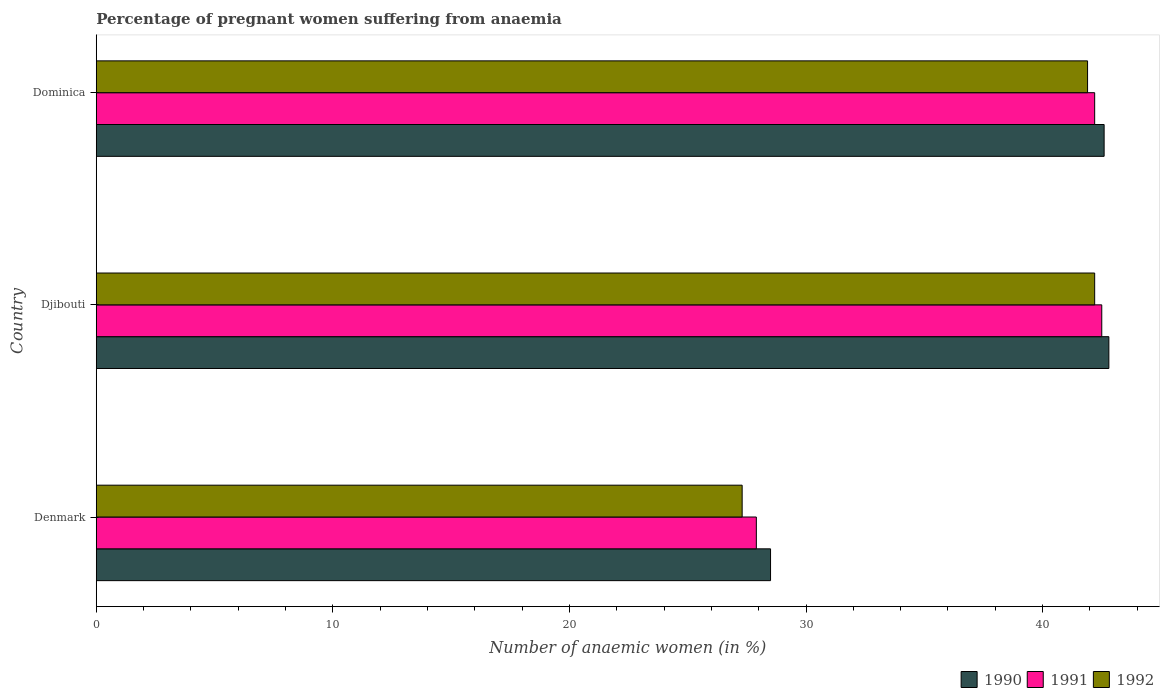How many bars are there on the 3rd tick from the bottom?
Ensure brevity in your answer.  3. What is the label of the 2nd group of bars from the top?
Your answer should be very brief. Djibouti. In how many cases, is the number of bars for a given country not equal to the number of legend labels?
Your answer should be compact. 0. What is the number of anaemic women in 1990 in Djibouti?
Provide a short and direct response. 42.8. Across all countries, what is the maximum number of anaemic women in 1990?
Your answer should be compact. 42.8. Across all countries, what is the minimum number of anaemic women in 1991?
Your answer should be very brief. 27.9. In which country was the number of anaemic women in 1991 maximum?
Your answer should be compact. Djibouti. In which country was the number of anaemic women in 1991 minimum?
Your answer should be compact. Denmark. What is the total number of anaemic women in 1991 in the graph?
Ensure brevity in your answer.  112.6. What is the difference between the number of anaemic women in 1991 in Djibouti and that in Dominica?
Your answer should be compact. 0.3. What is the difference between the number of anaemic women in 1990 in Djibouti and the number of anaemic women in 1991 in Dominica?
Keep it short and to the point. 0.6. What is the average number of anaemic women in 1991 per country?
Your answer should be very brief. 37.53. What is the difference between the number of anaemic women in 1991 and number of anaemic women in 1990 in Denmark?
Offer a very short reply. -0.6. What is the ratio of the number of anaemic women in 1990 in Djibouti to that in Dominica?
Your response must be concise. 1. Is the number of anaemic women in 1991 in Denmark less than that in Dominica?
Keep it short and to the point. Yes. Is the difference between the number of anaemic women in 1991 in Denmark and Djibouti greater than the difference between the number of anaemic women in 1990 in Denmark and Djibouti?
Provide a succinct answer. No. What is the difference between the highest and the second highest number of anaemic women in 1990?
Provide a succinct answer. 0.2. What is the difference between the highest and the lowest number of anaemic women in 1992?
Your response must be concise. 14.9. What does the 2nd bar from the top in Djibouti represents?
Offer a very short reply. 1991. Is it the case that in every country, the sum of the number of anaemic women in 1992 and number of anaemic women in 1991 is greater than the number of anaemic women in 1990?
Make the answer very short. Yes. How many bars are there?
Provide a succinct answer. 9. How many countries are there in the graph?
Your response must be concise. 3. What is the difference between two consecutive major ticks on the X-axis?
Give a very brief answer. 10. What is the title of the graph?
Your response must be concise. Percentage of pregnant women suffering from anaemia. What is the label or title of the X-axis?
Make the answer very short. Number of anaemic women (in %). What is the Number of anaemic women (in %) of 1990 in Denmark?
Your answer should be very brief. 28.5. What is the Number of anaemic women (in %) of 1991 in Denmark?
Offer a very short reply. 27.9. What is the Number of anaemic women (in %) in 1992 in Denmark?
Make the answer very short. 27.3. What is the Number of anaemic women (in %) in 1990 in Djibouti?
Ensure brevity in your answer.  42.8. What is the Number of anaemic women (in %) of 1991 in Djibouti?
Give a very brief answer. 42.5. What is the Number of anaemic women (in %) in 1992 in Djibouti?
Provide a succinct answer. 42.2. What is the Number of anaemic women (in %) of 1990 in Dominica?
Provide a short and direct response. 42.6. What is the Number of anaemic women (in %) of 1991 in Dominica?
Provide a short and direct response. 42.2. What is the Number of anaemic women (in %) in 1992 in Dominica?
Keep it short and to the point. 41.9. Across all countries, what is the maximum Number of anaemic women (in %) of 1990?
Offer a terse response. 42.8. Across all countries, what is the maximum Number of anaemic women (in %) in 1991?
Your answer should be very brief. 42.5. Across all countries, what is the maximum Number of anaemic women (in %) in 1992?
Your answer should be compact. 42.2. Across all countries, what is the minimum Number of anaemic women (in %) in 1990?
Your answer should be very brief. 28.5. Across all countries, what is the minimum Number of anaemic women (in %) in 1991?
Make the answer very short. 27.9. Across all countries, what is the minimum Number of anaemic women (in %) of 1992?
Give a very brief answer. 27.3. What is the total Number of anaemic women (in %) in 1990 in the graph?
Your answer should be very brief. 113.9. What is the total Number of anaemic women (in %) of 1991 in the graph?
Make the answer very short. 112.6. What is the total Number of anaemic women (in %) in 1992 in the graph?
Provide a succinct answer. 111.4. What is the difference between the Number of anaemic women (in %) in 1990 in Denmark and that in Djibouti?
Your response must be concise. -14.3. What is the difference between the Number of anaemic women (in %) in 1991 in Denmark and that in Djibouti?
Provide a succinct answer. -14.6. What is the difference between the Number of anaemic women (in %) in 1992 in Denmark and that in Djibouti?
Ensure brevity in your answer.  -14.9. What is the difference between the Number of anaemic women (in %) of 1990 in Denmark and that in Dominica?
Ensure brevity in your answer.  -14.1. What is the difference between the Number of anaemic women (in %) of 1991 in Denmark and that in Dominica?
Provide a short and direct response. -14.3. What is the difference between the Number of anaemic women (in %) in 1992 in Denmark and that in Dominica?
Provide a succinct answer. -14.6. What is the difference between the Number of anaemic women (in %) in 1990 in Djibouti and that in Dominica?
Make the answer very short. 0.2. What is the difference between the Number of anaemic women (in %) of 1991 in Djibouti and that in Dominica?
Your answer should be very brief. 0.3. What is the difference between the Number of anaemic women (in %) in 1990 in Denmark and the Number of anaemic women (in %) in 1991 in Djibouti?
Your answer should be compact. -14. What is the difference between the Number of anaemic women (in %) in 1990 in Denmark and the Number of anaemic women (in %) in 1992 in Djibouti?
Provide a short and direct response. -13.7. What is the difference between the Number of anaemic women (in %) in 1991 in Denmark and the Number of anaemic women (in %) in 1992 in Djibouti?
Offer a terse response. -14.3. What is the difference between the Number of anaemic women (in %) in 1990 in Denmark and the Number of anaemic women (in %) in 1991 in Dominica?
Make the answer very short. -13.7. What is the difference between the Number of anaemic women (in %) of 1990 in Denmark and the Number of anaemic women (in %) of 1992 in Dominica?
Provide a succinct answer. -13.4. What is the difference between the Number of anaemic women (in %) in 1990 in Djibouti and the Number of anaemic women (in %) in 1991 in Dominica?
Provide a succinct answer. 0.6. What is the average Number of anaemic women (in %) of 1990 per country?
Ensure brevity in your answer.  37.97. What is the average Number of anaemic women (in %) in 1991 per country?
Give a very brief answer. 37.53. What is the average Number of anaemic women (in %) in 1992 per country?
Your answer should be compact. 37.13. What is the difference between the Number of anaemic women (in %) of 1990 and Number of anaemic women (in %) of 1991 in Denmark?
Provide a short and direct response. 0.6. What is the difference between the Number of anaemic women (in %) of 1990 and Number of anaemic women (in %) of 1992 in Denmark?
Keep it short and to the point. 1.2. What is the difference between the Number of anaemic women (in %) of 1990 and Number of anaemic women (in %) of 1992 in Djibouti?
Offer a very short reply. 0.6. What is the difference between the Number of anaemic women (in %) of 1990 and Number of anaemic women (in %) of 1992 in Dominica?
Your response must be concise. 0.7. What is the difference between the Number of anaemic women (in %) of 1991 and Number of anaemic women (in %) of 1992 in Dominica?
Ensure brevity in your answer.  0.3. What is the ratio of the Number of anaemic women (in %) of 1990 in Denmark to that in Djibouti?
Offer a very short reply. 0.67. What is the ratio of the Number of anaemic women (in %) of 1991 in Denmark to that in Djibouti?
Offer a very short reply. 0.66. What is the ratio of the Number of anaemic women (in %) in 1992 in Denmark to that in Djibouti?
Provide a short and direct response. 0.65. What is the ratio of the Number of anaemic women (in %) of 1990 in Denmark to that in Dominica?
Make the answer very short. 0.67. What is the ratio of the Number of anaemic women (in %) in 1991 in Denmark to that in Dominica?
Offer a terse response. 0.66. What is the ratio of the Number of anaemic women (in %) in 1992 in Denmark to that in Dominica?
Provide a succinct answer. 0.65. What is the ratio of the Number of anaemic women (in %) in 1990 in Djibouti to that in Dominica?
Offer a terse response. 1. What is the ratio of the Number of anaemic women (in %) of 1991 in Djibouti to that in Dominica?
Keep it short and to the point. 1.01. What is the ratio of the Number of anaemic women (in %) in 1992 in Djibouti to that in Dominica?
Give a very brief answer. 1.01. What is the difference between the highest and the second highest Number of anaemic women (in %) in 1990?
Your answer should be very brief. 0.2. What is the difference between the highest and the second highest Number of anaemic women (in %) of 1992?
Ensure brevity in your answer.  0.3. What is the difference between the highest and the lowest Number of anaemic women (in %) of 1990?
Offer a terse response. 14.3. What is the difference between the highest and the lowest Number of anaemic women (in %) of 1991?
Your answer should be compact. 14.6. What is the difference between the highest and the lowest Number of anaemic women (in %) of 1992?
Make the answer very short. 14.9. 